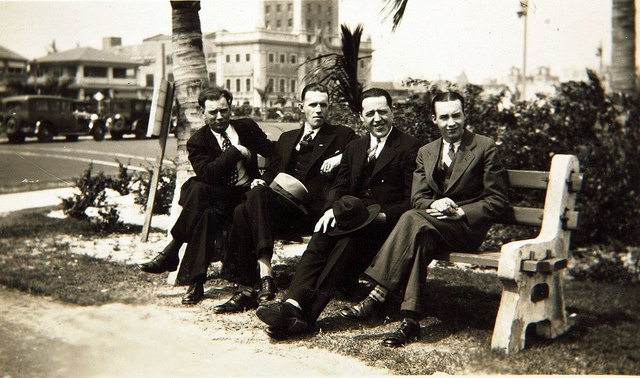Describe the objects in this image and their specific colors. I can see people in ivory, black, and gray tones, bench in ivory, black, and gray tones, people in ivory, black, and gray tones, people in ivory, black, gray, and darkgray tones, and people in ivory, black, and gray tones in this image. 